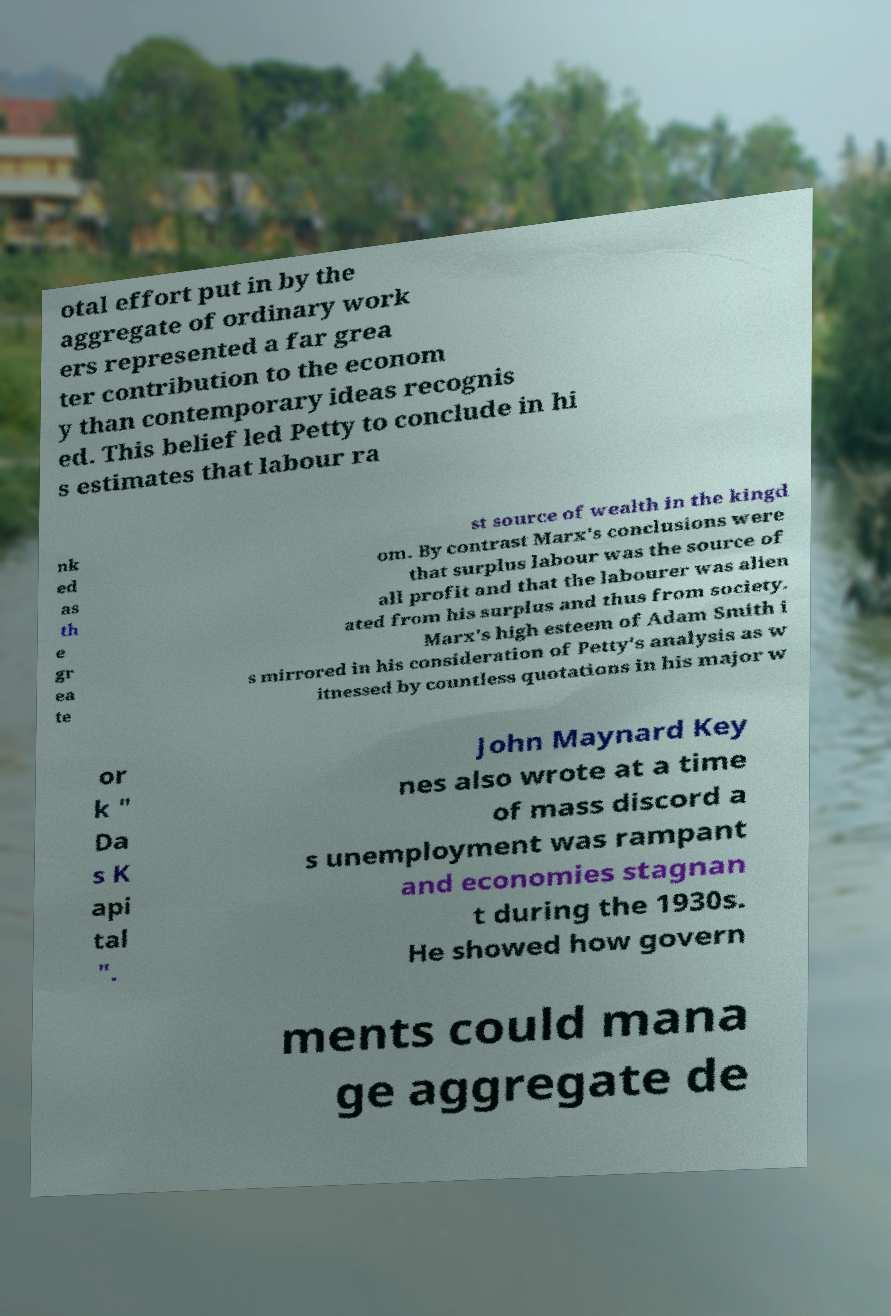Could you assist in decoding the text presented in this image and type it out clearly? otal effort put in by the aggregate of ordinary work ers represented a far grea ter contribution to the econom y than contemporary ideas recognis ed. This belief led Petty to conclude in hi s estimates that labour ra nk ed as th e gr ea te st source of wealth in the kingd om. By contrast Marx's conclusions were that surplus labour was the source of all profit and that the labourer was alien ated from his surplus and thus from society. Marx's high esteem of Adam Smith i s mirrored in his consideration of Petty's analysis as w itnessed by countless quotations in his major w or k " Da s K api tal ". John Maynard Key nes also wrote at a time of mass discord a s unemployment was rampant and economies stagnan t during the 1930s. He showed how govern ments could mana ge aggregate de 